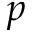<formula> <loc_0><loc_0><loc_500><loc_500>p</formula> 